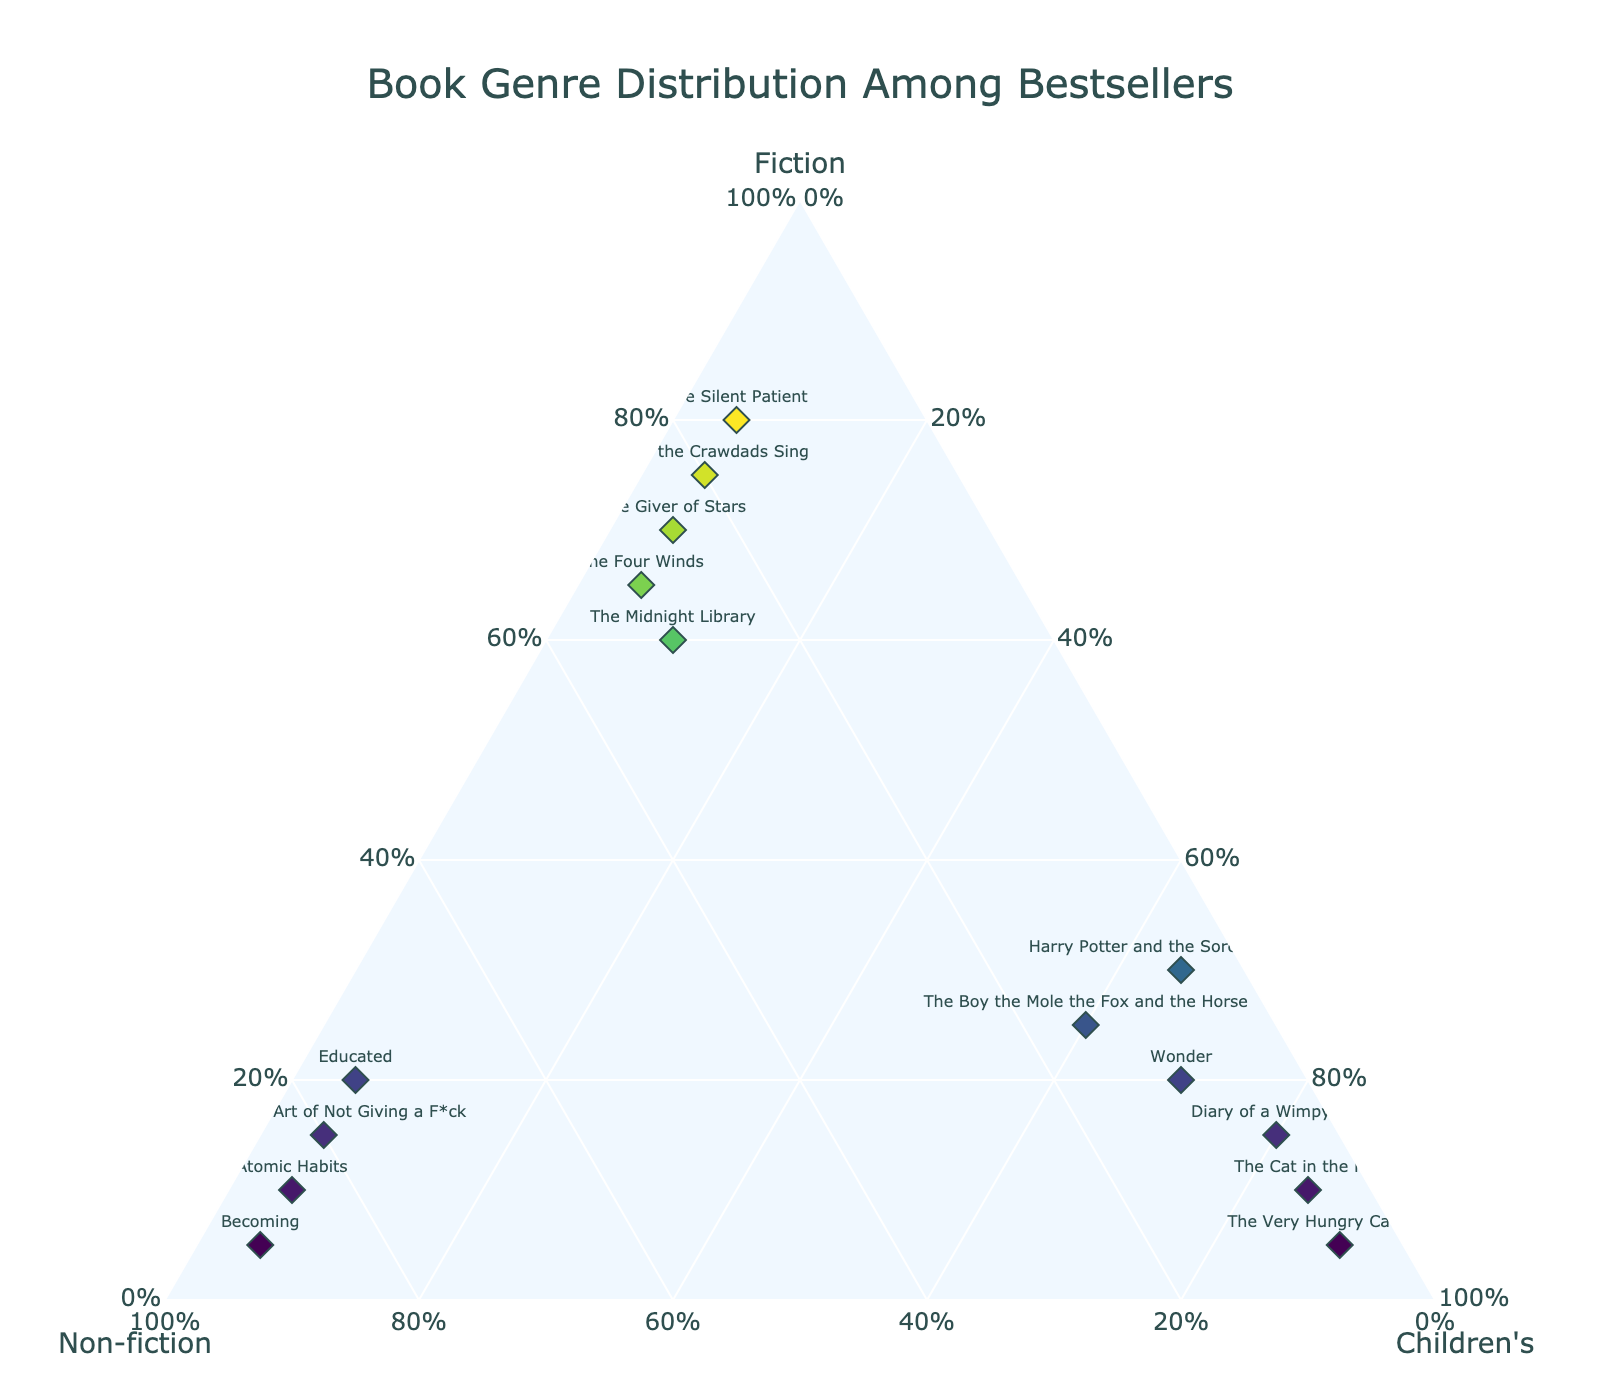What is the title of the figure? The title is usually displayed at the top of the figure. In this case, it reads "Book Genre Distribution Among Bestsellers."
Answer: Book Genre Distribution Among Bestsellers Which book is closest to having an equal distribution among all three genres? By looking at the points on the ternary plot, "The Midnight Library" with 0.60 Fiction, 0.30 Non-fiction, and 0.10 Children's is closest to an equal distribution.
Answer: The Midnight Library How many books have a higher proportion of Non-fiction than Fiction? Verify each data point on the ternary plot; the titles with more Non-fiction than Fiction are "Atomic Habits," "Becoming," "The Subtle Art of Not Giving a F*ck," and "Educated."
Answer: Four Which book has the highest proportion of Children's genre? On the plot, the point that is the furthest towards the Children's corner indicates the highest proportion. That's "The Very Hungry Caterpillar" with 0.90 Children's.
Answer: The Very Hungry Caterpillar Is "Becoming" categorized more under Fiction, Non-fiction, or Children's genre? Check the values for "Becoming" on the plot: 0.05 Fiction, 0.90 Non-fiction, and 0.05 Children's. Thus, Non-fiction is the highest.
Answer: Non-fiction What is the average Non-fiction proportion among all books? Calculate the average by summing up the Non-fiction values (0.30 + 0.20 + 0.85 + 0.15 + 0.90 + 0.05 + 0.80 + 0.05 + 0.75 + 0.25 + 0.10 + 0.15 + 0.05 + 0.30 + 0.05) and dividing by the number of books (15). The sum is 4.75, so the average is 4.75/15 = 0.3167.
Answer: 0.3167 Compare the proportions of Fiction and Children’s for "Diary of a Wimpy Kid". Which is higher? Check the values: "Diary of a Wimpy Kid" has 0.15 Fiction and 0.80 Children's.
Answer: Children’s Which book has the highest proportion of Fiction? Check which point is closest to the Fiction corner. "The Silent Patient" with 0.80 Fiction has the highest proportion.
Answer: The Silent Patient What is the combined proportion of Non-fiction and Children's genres for "The Boy the Mole the Fox and the Horse"? Add the proportions of Non-fiction (0.15) and Children's (0.60) for "The Boy the Mole the Fox and the Horse". 0.15 + 0.60 = 0.75.
Answer: 0.75 Which book has equal proportions of Non-fiction and Children's genres? Find the point where the Non-fiction and Children's proportions are the same. "The Very Hungry Caterpillar" has both at 0.05.
Answer: The Very Hungry Caterpillar 